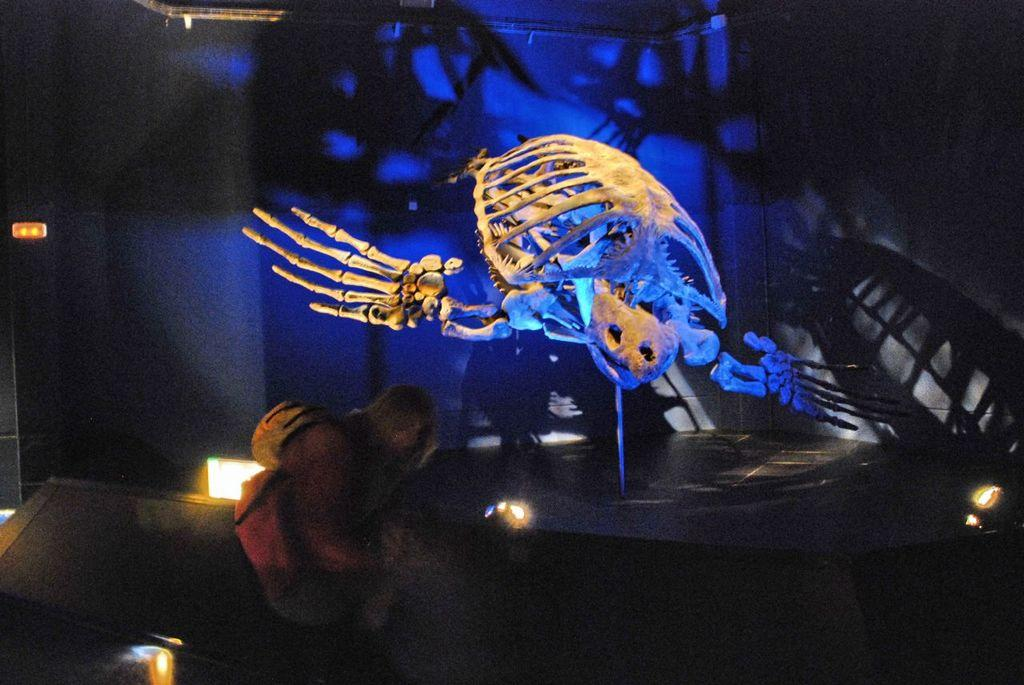What is the main subject of the image? The main subject of the image is a skeleton of an animal. What else can be seen in the image besides the skeleton? There is a human wearing a backpack and lights visible in the image. What is in the background of the image? There is a wall in the background of the image. What type of bun is being held by the skeleton in the image? There is no bun present in the image; it features a skeleton of an animal, a human wearing a backpack, lights, and a wall in the background. 